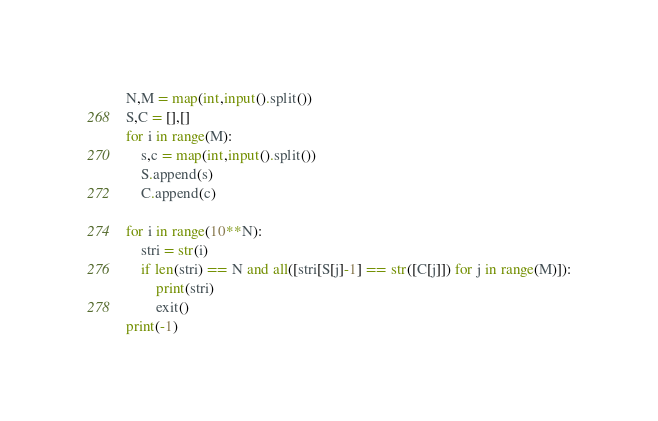Convert code to text. <code><loc_0><loc_0><loc_500><loc_500><_Python_>N,M = map(int,input().split())
S,C = [],[]
for i in range(M):
    s,c = map(int,input().split())
    S.append(s)
    C.append(c)

for i in range(10**N):
    stri = str(i)
    if len(stri) == N and all([stri[S[j]-1] == str([C[j]]) for j in range(M)]):
        print(stri)
        exit()
print(-1)
</code> 